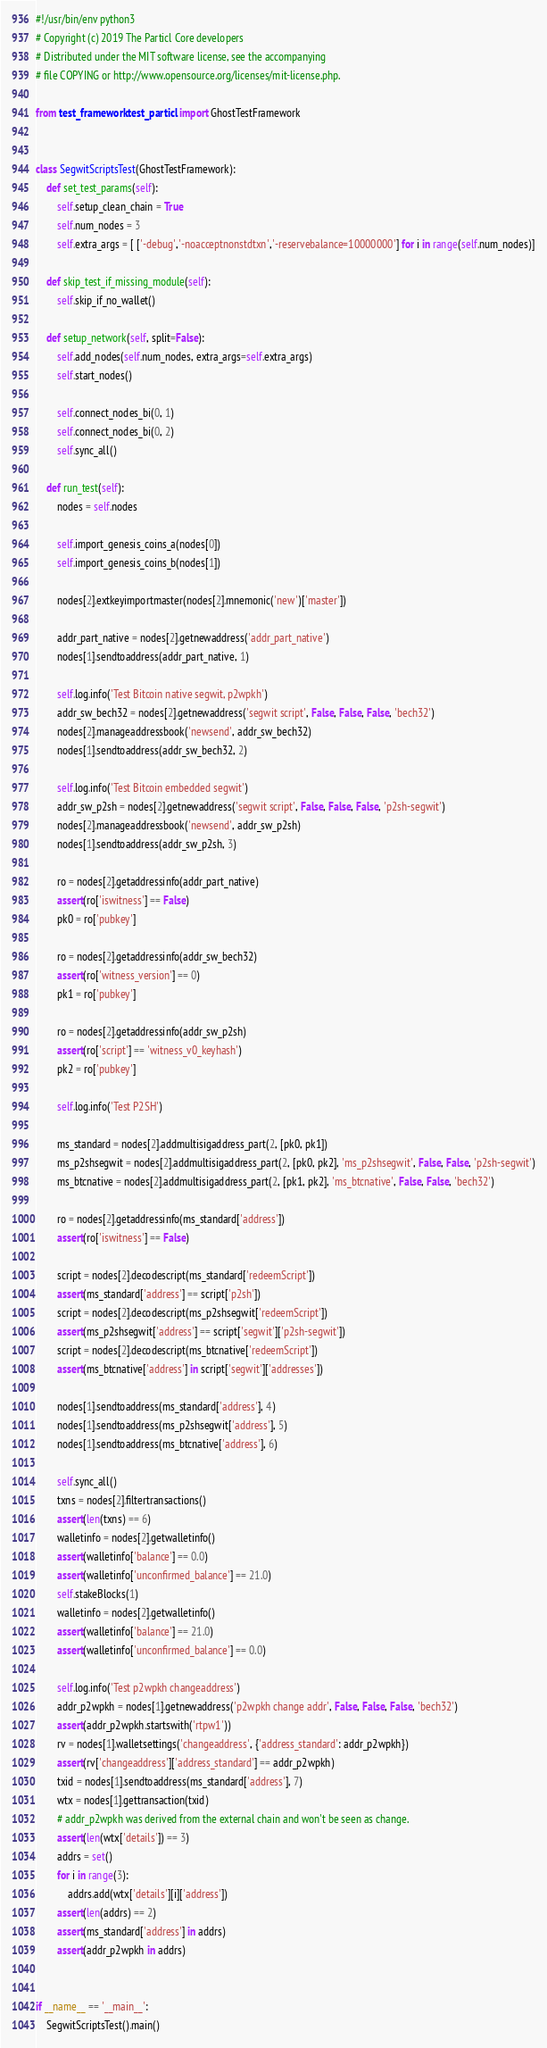<code> <loc_0><loc_0><loc_500><loc_500><_Python_>#!/usr/bin/env python3
# Copyright (c) 2019 The Particl Core developers
# Distributed under the MIT software license, see the accompanying
# file COPYING or http://www.opensource.org/licenses/mit-license.php.

from test_framework.test_particl import GhostTestFramework


class SegwitScriptsTest(GhostTestFramework):
    def set_test_params(self):
        self.setup_clean_chain = True
        self.num_nodes = 3
        self.extra_args = [ ['-debug','-noacceptnonstdtxn','-reservebalance=10000000'] for i in range(self.num_nodes)]

    def skip_test_if_missing_module(self):
        self.skip_if_no_wallet()

    def setup_network(self, split=False):
        self.add_nodes(self.num_nodes, extra_args=self.extra_args)
        self.start_nodes()

        self.connect_nodes_bi(0, 1)
        self.connect_nodes_bi(0, 2)
        self.sync_all()

    def run_test(self):
        nodes = self.nodes

        self.import_genesis_coins_a(nodes[0])
        self.import_genesis_coins_b(nodes[1])

        nodes[2].extkeyimportmaster(nodes[2].mnemonic('new')['master'])

        addr_part_native = nodes[2].getnewaddress('addr_part_native')
        nodes[1].sendtoaddress(addr_part_native, 1)

        self.log.info('Test Bitcoin native segwit, p2wpkh')
        addr_sw_bech32 = nodes[2].getnewaddress('segwit script', False, False, False, 'bech32')
        nodes[2].manageaddressbook('newsend', addr_sw_bech32)
        nodes[1].sendtoaddress(addr_sw_bech32, 2)

        self.log.info('Test Bitcoin embedded segwit')
        addr_sw_p2sh = nodes[2].getnewaddress('segwit script', False, False, False, 'p2sh-segwit')
        nodes[2].manageaddressbook('newsend', addr_sw_p2sh)
        nodes[1].sendtoaddress(addr_sw_p2sh, 3)

        ro = nodes[2].getaddressinfo(addr_part_native)
        assert(ro['iswitness'] == False)
        pk0 = ro['pubkey']

        ro = nodes[2].getaddressinfo(addr_sw_bech32)
        assert(ro['witness_version'] == 0)
        pk1 = ro['pubkey']

        ro = nodes[2].getaddressinfo(addr_sw_p2sh)
        assert(ro['script'] == 'witness_v0_keyhash')
        pk2 = ro['pubkey']

        self.log.info('Test P2SH')

        ms_standard = nodes[2].addmultisigaddress_part(2, [pk0, pk1])
        ms_p2shsegwit = nodes[2].addmultisigaddress_part(2, [pk0, pk2], 'ms_p2shsegwit', False, False, 'p2sh-segwit')
        ms_btcnative = nodes[2].addmultisigaddress_part(2, [pk1, pk2], 'ms_btcnative', False, False, 'bech32')

        ro = nodes[2].getaddressinfo(ms_standard['address'])
        assert(ro['iswitness'] == False)

        script = nodes[2].decodescript(ms_standard['redeemScript'])
        assert(ms_standard['address'] == script['p2sh'])
        script = nodes[2].decodescript(ms_p2shsegwit['redeemScript'])
        assert(ms_p2shsegwit['address'] == script['segwit']['p2sh-segwit'])
        script = nodes[2].decodescript(ms_btcnative['redeemScript'])
        assert(ms_btcnative['address'] in script['segwit']['addresses'])

        nodes[1].sendtoaddress(ms_standard['address'], 4)
        nodes[1].sendtoaddress(ms_p2shsegwit['address'], 5)
        nodes[1].sendtoaddress(ms_btcnative['address'], 6)

        self.sync_all()
        txns = nodes[2].filtertransactions()
        assert(len(txns) == 6)
        walletinfo = nodes[2].getwalletinfo()
        assert(walletinfo['balance'] == 0.0)
        assert(walletinfo['unconfirmed_balance'] == 21.0)
        self.stakeBlocks(1)
        walletinfo = nodes[2].getwalletinfo()
        assert(walletinfo['balance'] == 21.0)
        assert(walletinfo['unconfirmed_balance'] == 0.0)

        self.log.info('Test p2wpkh changeaddress')
        addr_p2wpkh = nodes[1].getnewaddress('p2wpkh change addr', False, False, False, 'bech32')
        assert(addr_p2wpkh.startswith('rtpw1'))
        rv = nodes[1].walletsettings('changeaddress', {'address_standard': addr_p2wpkh})
        assert(rv['changeaddress']['address_standard'] == addr_p2wpkh)
        txid = nodes[1].sendtoaddress(ms_standard['address'], 7)
        wtx = nodes[1].gettransaction(txid)
        # addr_p2wpkh was derived from the external chain and won't be seen as change.
        assert(len(wtx['details']) == 3)
        addrs = set()
        for i in range(3):
            addrs.add(wtx['details'][i]['address'])
        assert(len(addrs) == 2)
        assert(ms_standard['address'] in addrs)
        assert(addr_p2wpkh in addrs)


if __name__ == '__main__':
    SegwitScriptsTest().main()
</code> 